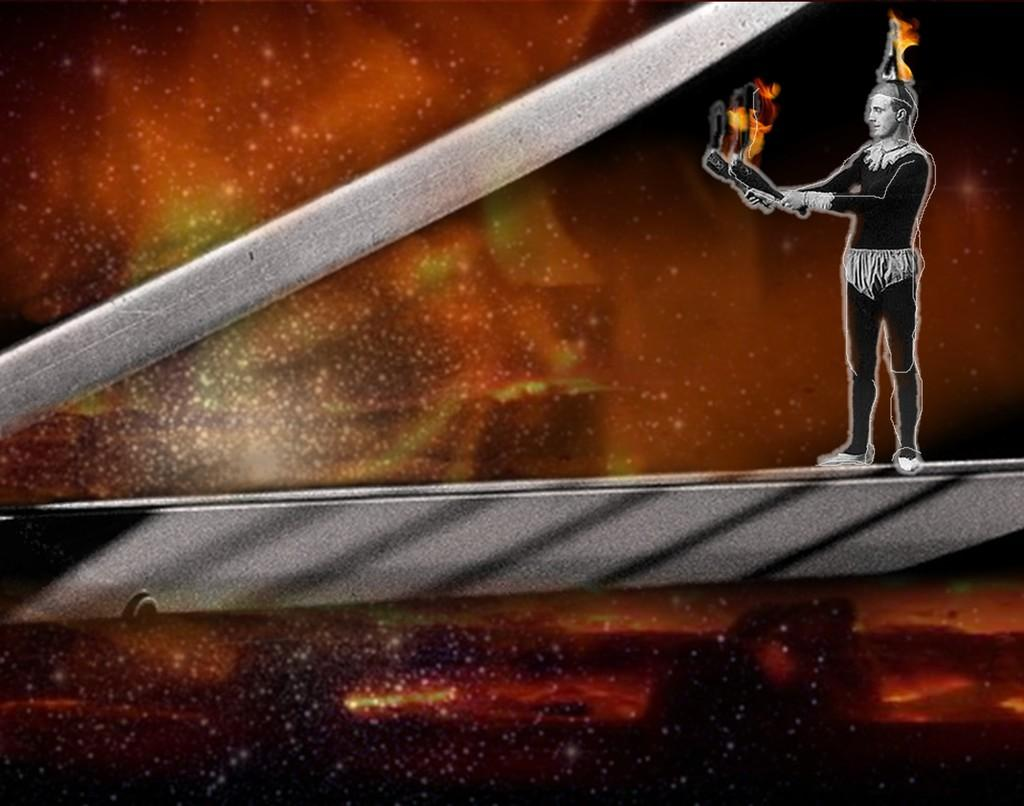Who is present in the image? There is a man in the image. Where is the man located in the image? The man is on the top right side of the image. What is the man holding in his hands? The man is holding flammable objects in his hands. What type of footwear is the man's sister wearing in the image? There is no mention of a sister or footwear in the image, so it cannot be determined. 